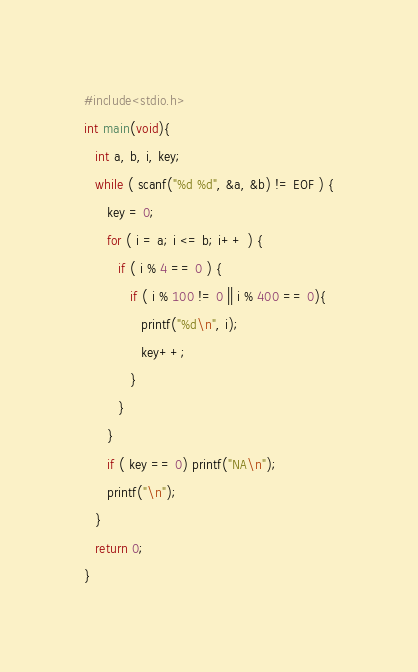<code> <loc_0><loc_0><loc_500><loc_500><_C_>#include<stdio.h>
int main(void){
   int a, b, i, key;
   while ( scanf("%d %d", &a, &b) != EOF ) {
      key = 0;
      for ( i = a; i <= b; i++ ) {
         if ( i % 4 == 0 ) {
            if ( i % 100 != 0 || i % 400 == 0){
               printf("%d\n", i);
               key++;
            }
         }
      }
      if ( key == 0) printf("NA\n");
      printf("\n");
   }
   return 0;
}</code> 